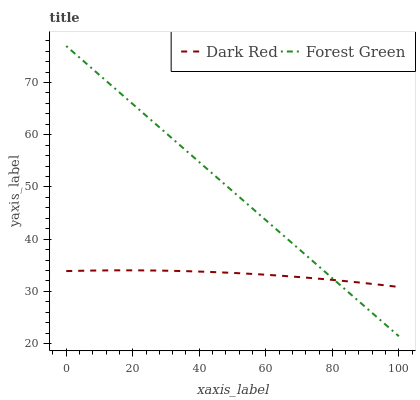Does Dark Red have the minimum area under the curve?
Answer yes or no. Yes. Does Forest Green have the maximum area under the curve?
Answer yes or no. Yes. Does Forest Green have the minimum area under the curve?
Answer yes or no. No. Is Forest Green the smoothest?
Answer yes or no. Yes. Is Dark Red the roughest?
Answer yes or no. Yes. Is Forest Green the roughest?
Answer yes or no. No. Does Forest Green have the lowest value?
Answer yes or no. Yes. Does Forest Green have the highest value?
Answer yes or no. Yes. Does Dark Red intersect Forest Green?
Answer yes or no. Yes. Is Dark Red less than Forest Green?
Answer yes or no. No. Is Dark Red greater than Forest Green?
Answer yes or no. No. 